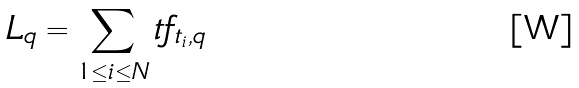<formula> <loc_0><loc_0><loc_500><loc_500>L _ { q } = \sum _ { 1 \leq i \leq N } t f _ { t _ { i } , q }</formula> 